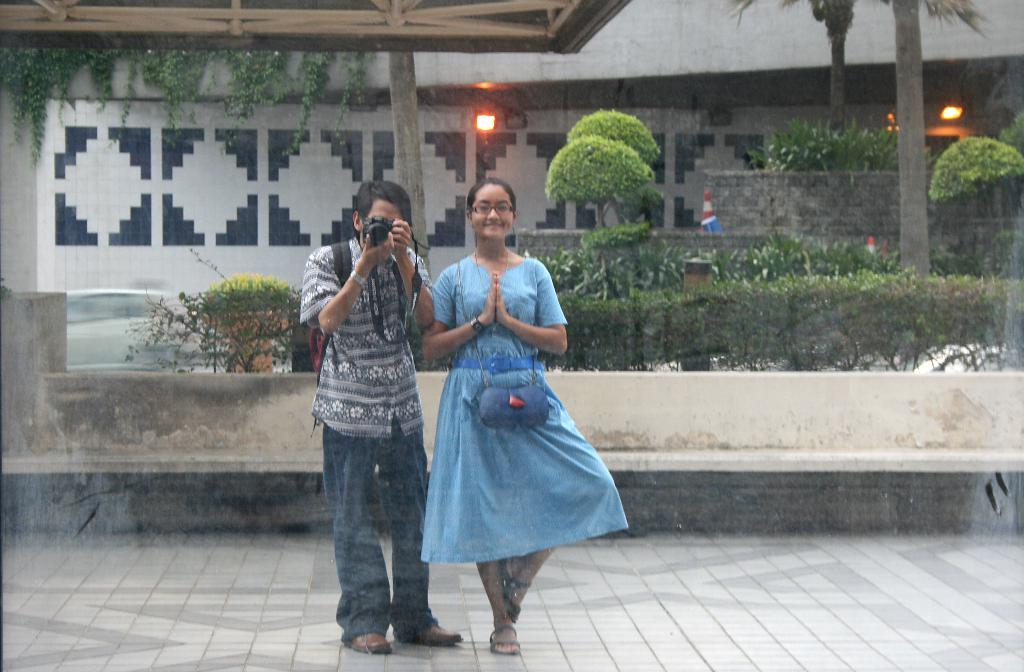How many people are present in the image? There is a man and a woman in the image. What is the man holding in his hands? The man is holding a camera in his hands. What can be seen in the background of the image? There are plants, lights, a wall, and trees in the background of the image. Can you tell me how many kittens are sitting on the man's feet in the image? There are no kittens or feet visible in the image; it only shows a man and a woman with a camera. 